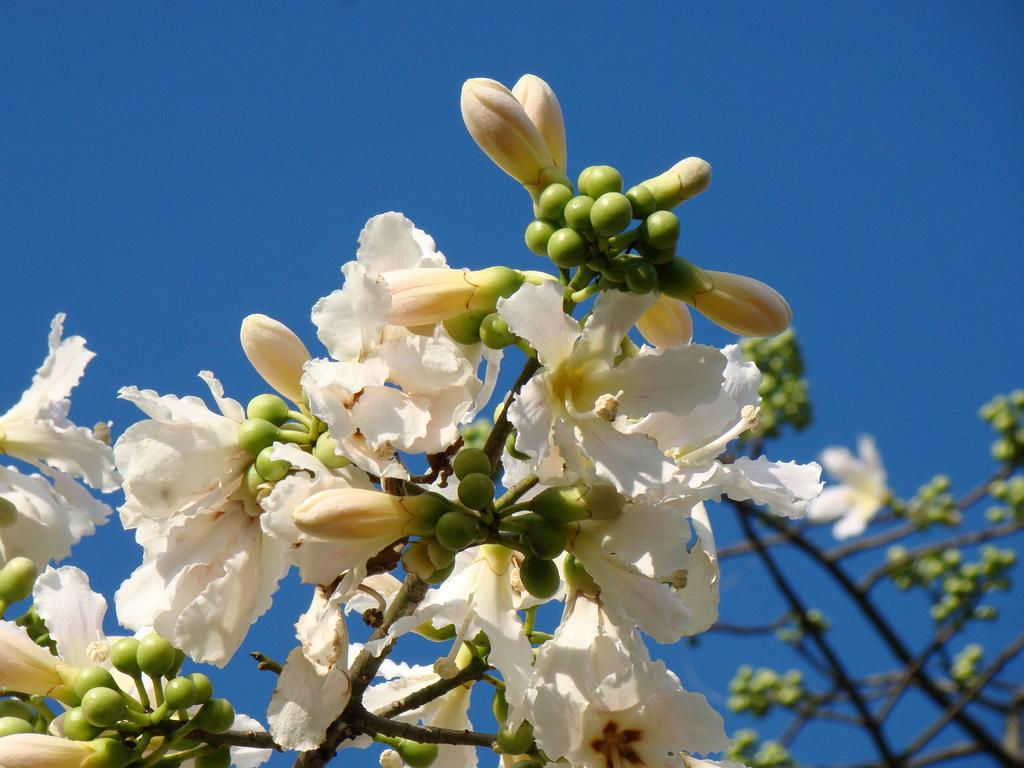What types of natural objects are present in the image? There are fruits and flowers in the image. What color are the fruits and flowers in the image? The fruits and flowers in the image are white in color. What can be seen in the background of the image? There is a sky visible in the background of the image. Is there a knife being used to cut the white fruits in the image? There is no knife present in the image, and the fruits are not being cut. 